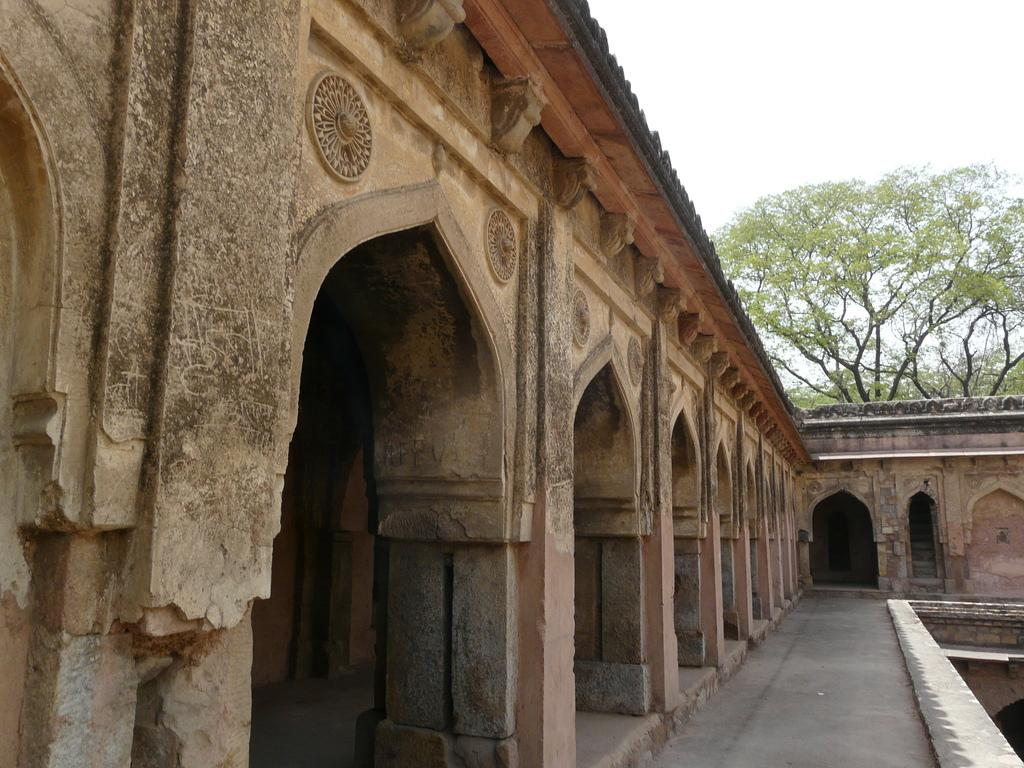What type of architectural feature can be seen in the image? There are arches with sculptures in the image. What else is present in the image besides the arches? There is a wall visible in the image. What type of natural elements can be seen in the image? There are trees in the image. What is visible in the background of the image? The sky is visible in the image. What type of quartz can be seen in the image? There is no quartz present in the image. Did the arches collapse due to an earthquake in the image? There is no indication of an earthquake or any damage to the arches in the image. 